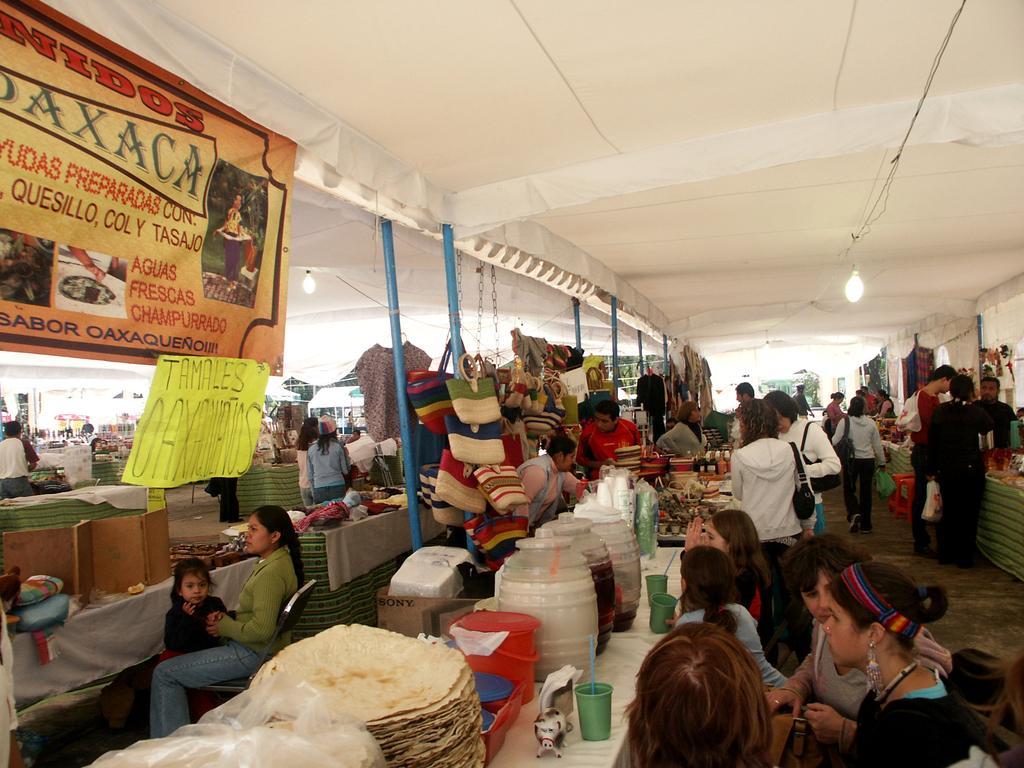Could you give a brief overview of what you see in this image? In this image I can see the group of people and few people are standing and few people are sitting. I can see few food items, jars, glasses, cardboard boxes and few objects on the tables. I can see few clothes, bags are attached to the poles. I can see few poles, lights, banners and the cloth ceiling. 